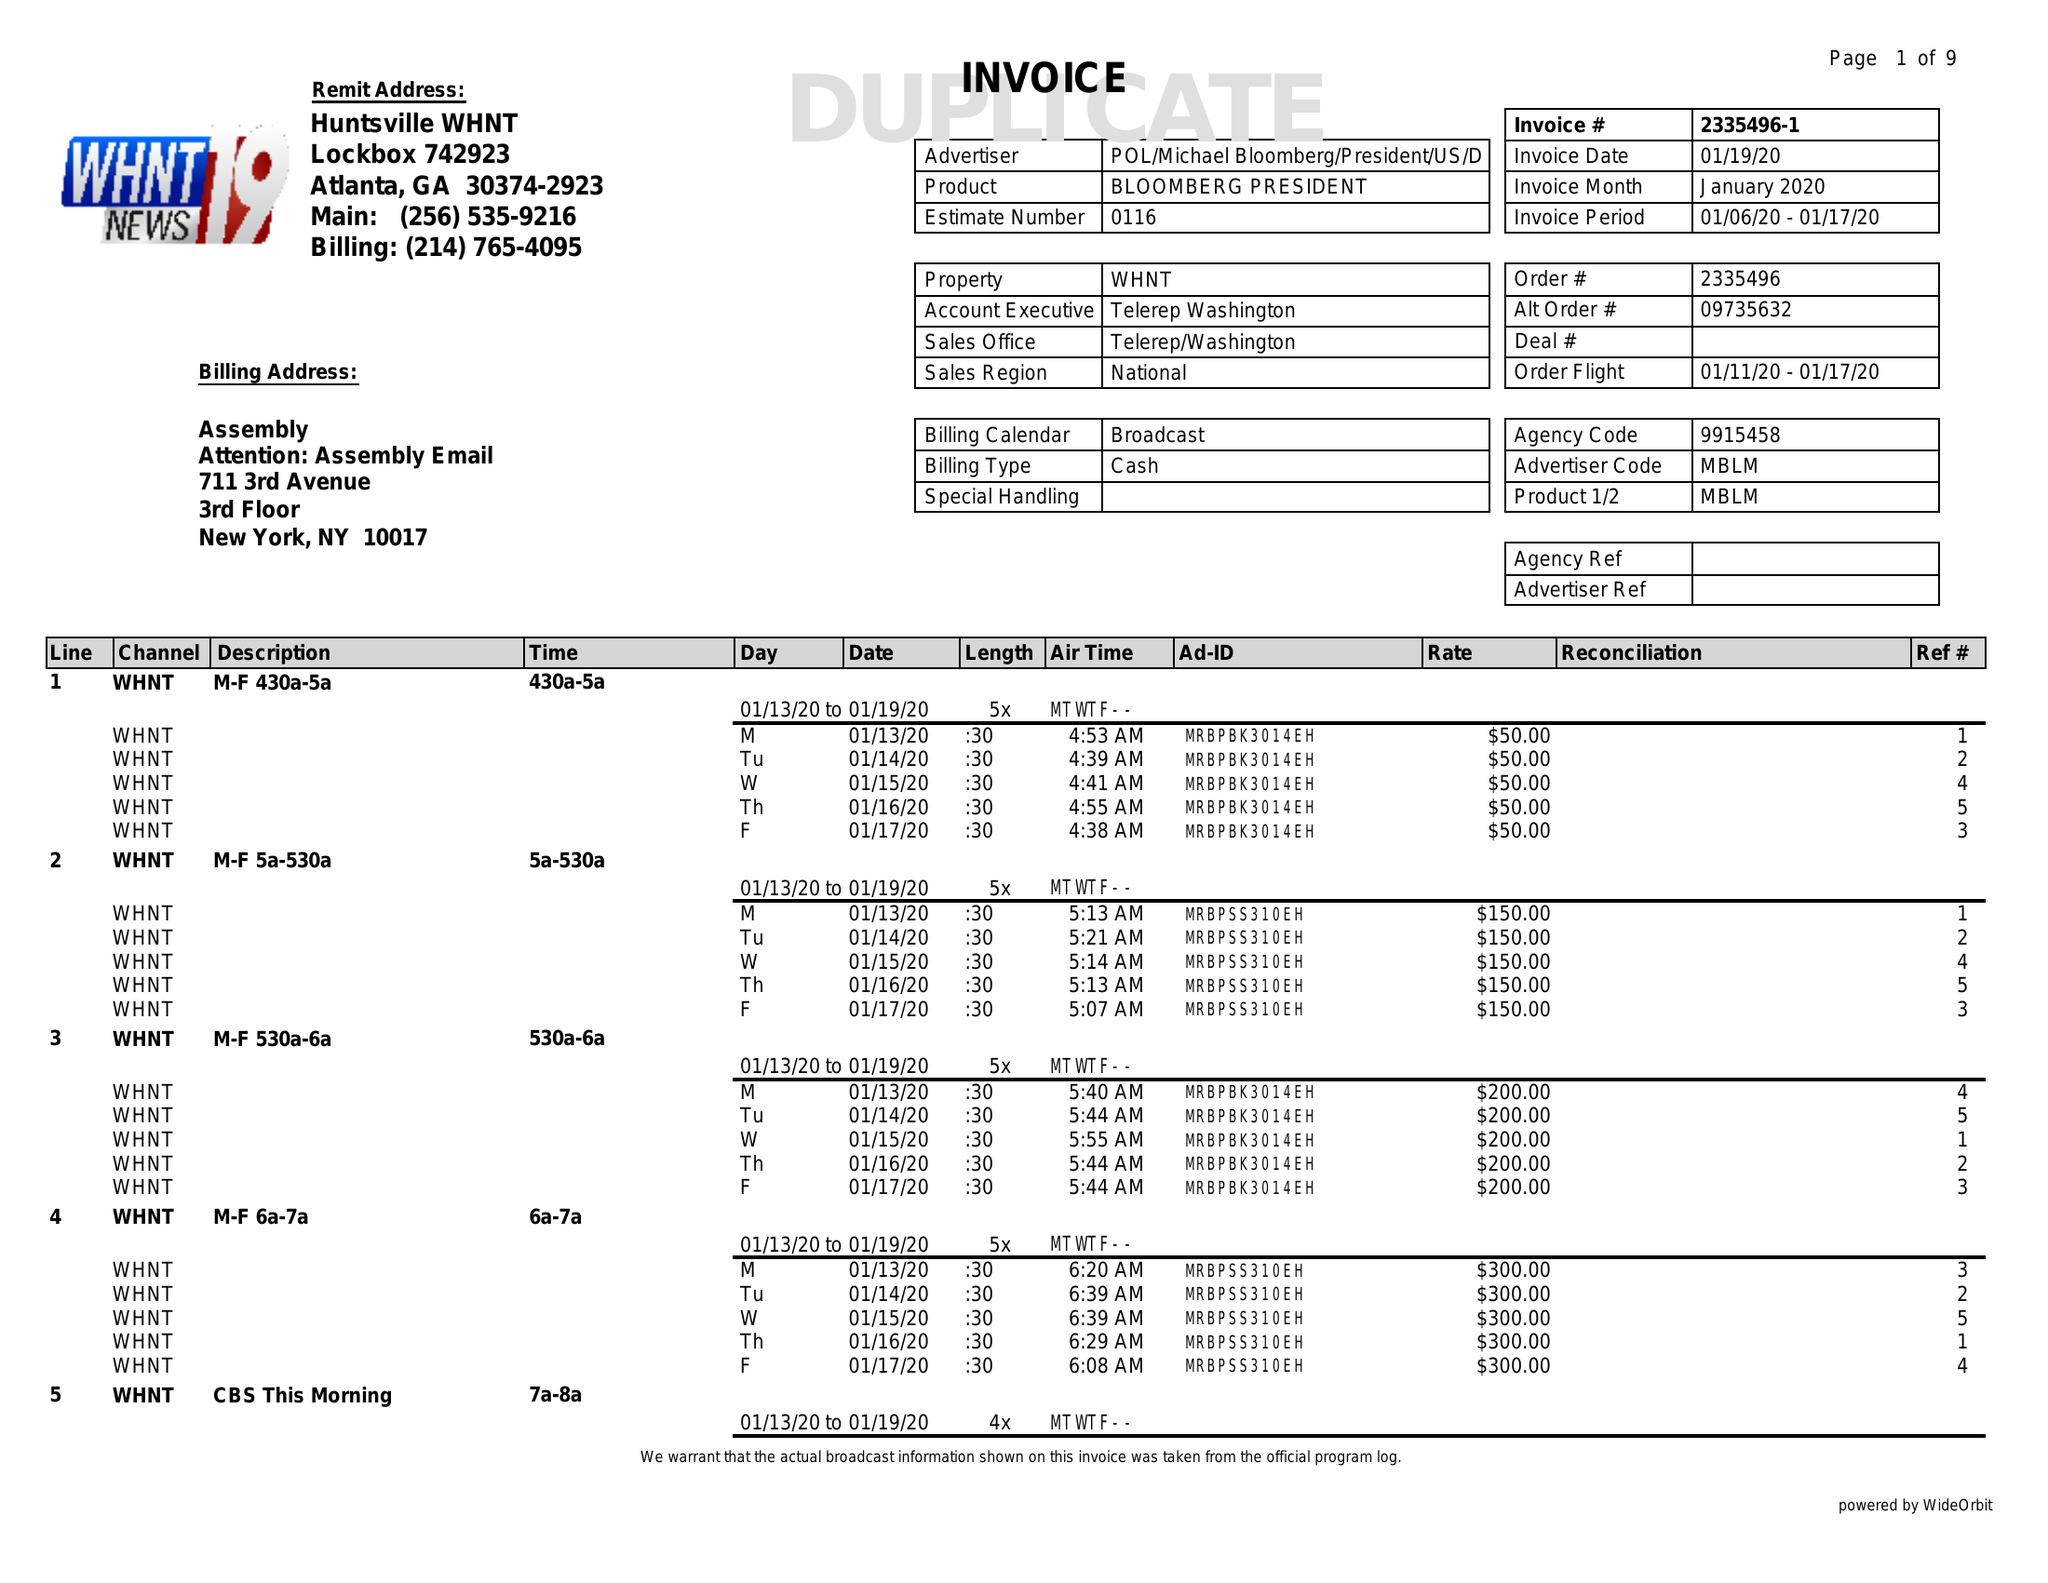What is the value for the flight_to?
Answer the question using a single word or phrase. 01/17/20 